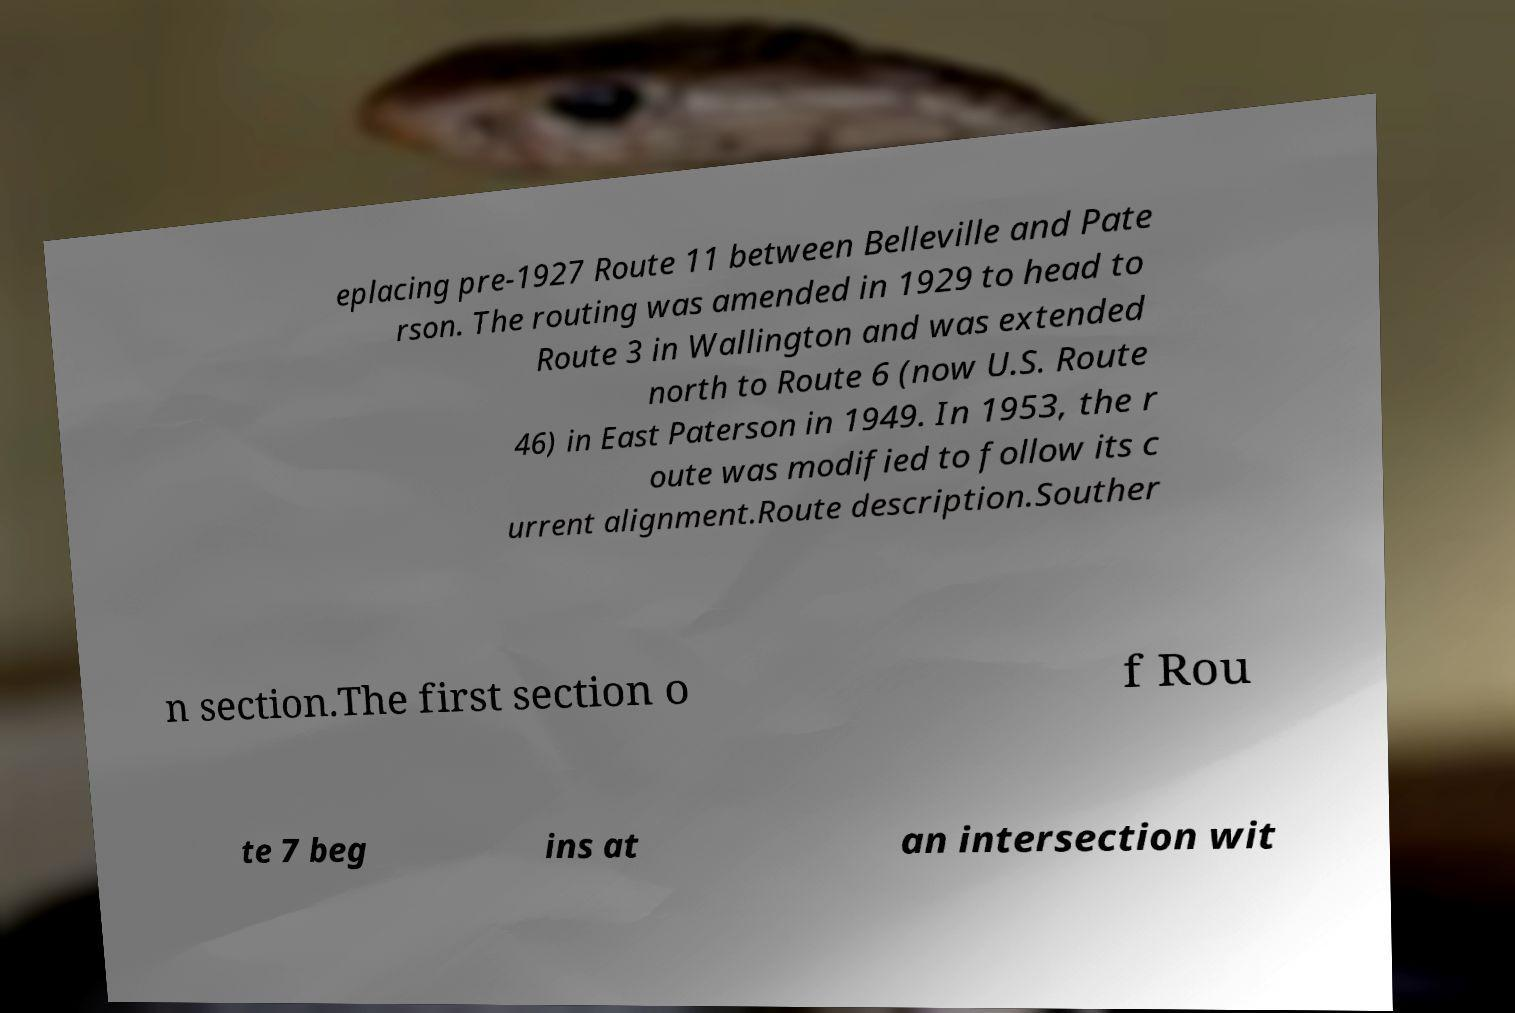Could you extract and type out the text from this image? eplacing pre-1927 Route 11 between Belleville and Pate rson. The routing was amended in 1929 to head to Route 3 in Wallington and was extended north to Route 6 (now U.S. Route 46) in East Paterson in 1949. In 1953, the r oute was modified to follow its c urrent alignment.Route description.Souther n section.The first section o f Rou te 7 beg ins at an intersection wit 